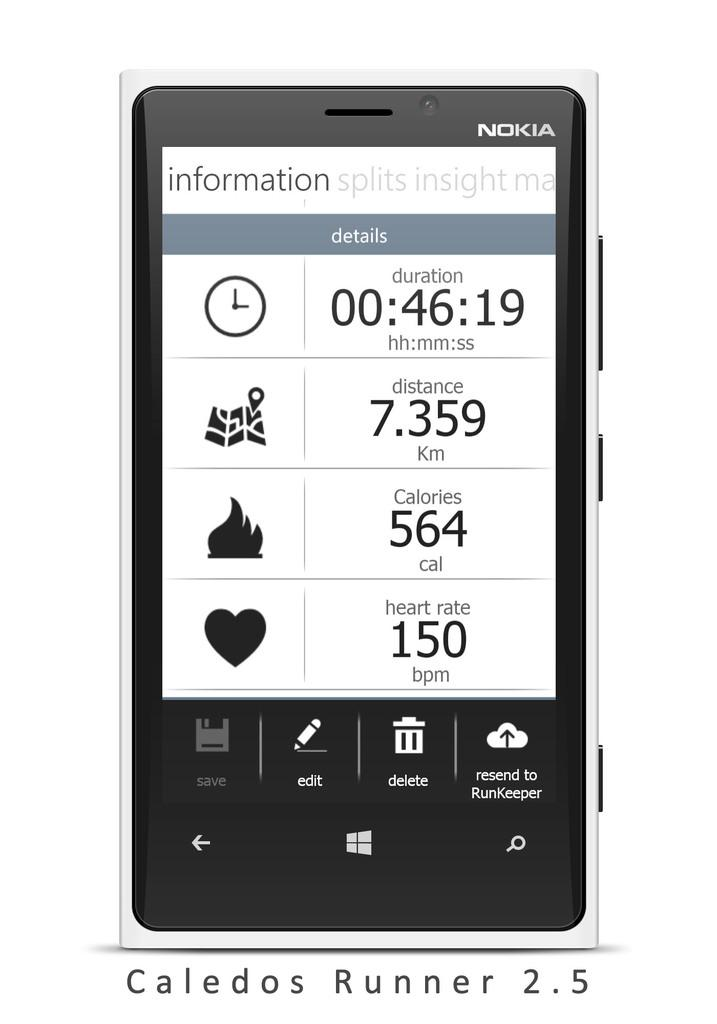<image>
Write a terse but informative summary of the picture. The Nokia phone shows heart rate and calories burned. 